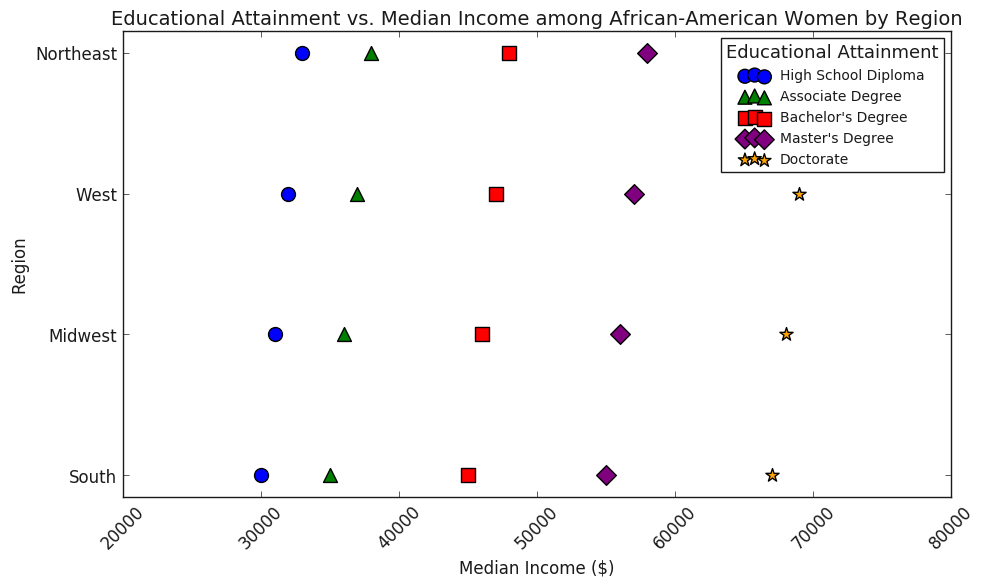What's the difference in Median Income between African-American women with a High School Diploma in the South and a Doctorate in the Northeast? To find the difference, identify the median incomes for both: High School Diploma in the South is $30,000, and a Doctorate in the Northeast is $70,000. Subtract the smaller value from the larger one: 70,000 - 30,000 = 40,000.
Answer: 40,000 Which educational attainment has the highest median income in the Midwest region? Look at the data points in the Midwest region and find the highest median income. Doctorate holds the highest median income at $68,000.
Answer: Doctorate Is there a region where the median income for African-American women with a Bachelor's Degree is higher than for those with a Master's Degree? Compare median incomes for Bachelor's and Master's degrees across all regions. In all regions, Master’s Degree has higher median income ($55,000 - $58,000) compared to Bachelor's Degree ($45,000 - $48,000)
Answer: No Which region shows the highest variation in median income across all educational attainment levels? Look at the range of median incomes across educational attainments in each region: South has a range from $30,000 to $67,000, Midwest from $31,000 to $68,000, West from $32,000 to $69,000, and Northeast from $33,000 to $70,000. The Northeast shows the highest range of 33,000 to 70,000.
Answer: Northeast Which educational attainment is represented by blue markers? Refer to the legend in the plot. The blue marker represents High School Diploma.
Answer: High School Diploma How does the median income for African-American women with an Associate Degree in the West compare to those with a Bachelor's Degree in the South? Find the median incomes: Associate Degree in the West is $37,000 and Bachelor's Degree in the South is $45,000. Bachelor’s Degree in the South is higher.
Answer: Bachelor's Degree in the South What is the median income range for African-American women with a Master's Degree across all regions? Identify the highest and lowest median incomes for Master’s Degree: $55,000 in the South, $56,000 in the Midwest, $57,000 in the West, and $58,000 in the Northeast. The range is $55,000 to $58,000.
Answer: $55,000 - $58,000 Which region has the lowest median income for African-American women with a Doctorate? Compare the median incomes for Doctorate across regions: $67,000 in the South, $68,000 in the Midwest, $69,000 in the West, and $70,000 in the Northeast. The South has the lowest at $67,000.
Answer: South Is there a direct correlation between educational attainment level and median income for African-American women? Notice the trend that higher educational attainment corresponds to higher median income across all regions.
Answer: Yes 